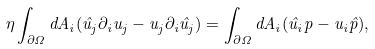<formula> <loc_0><loc_0><loc_500><loc_500>\eta \int _ { \partial \Omega } d A _ { i } ( \hat { u } _ { j } \partial _ { i } u _ { j } - u _ { j } \partial _ { i } \hat { u } _ { j } ) = \int _ { \partial \Omega } d A _ { i } ( \hat { u } _ { i } p - u _ { i } \hat { p } ) ,</formula> 